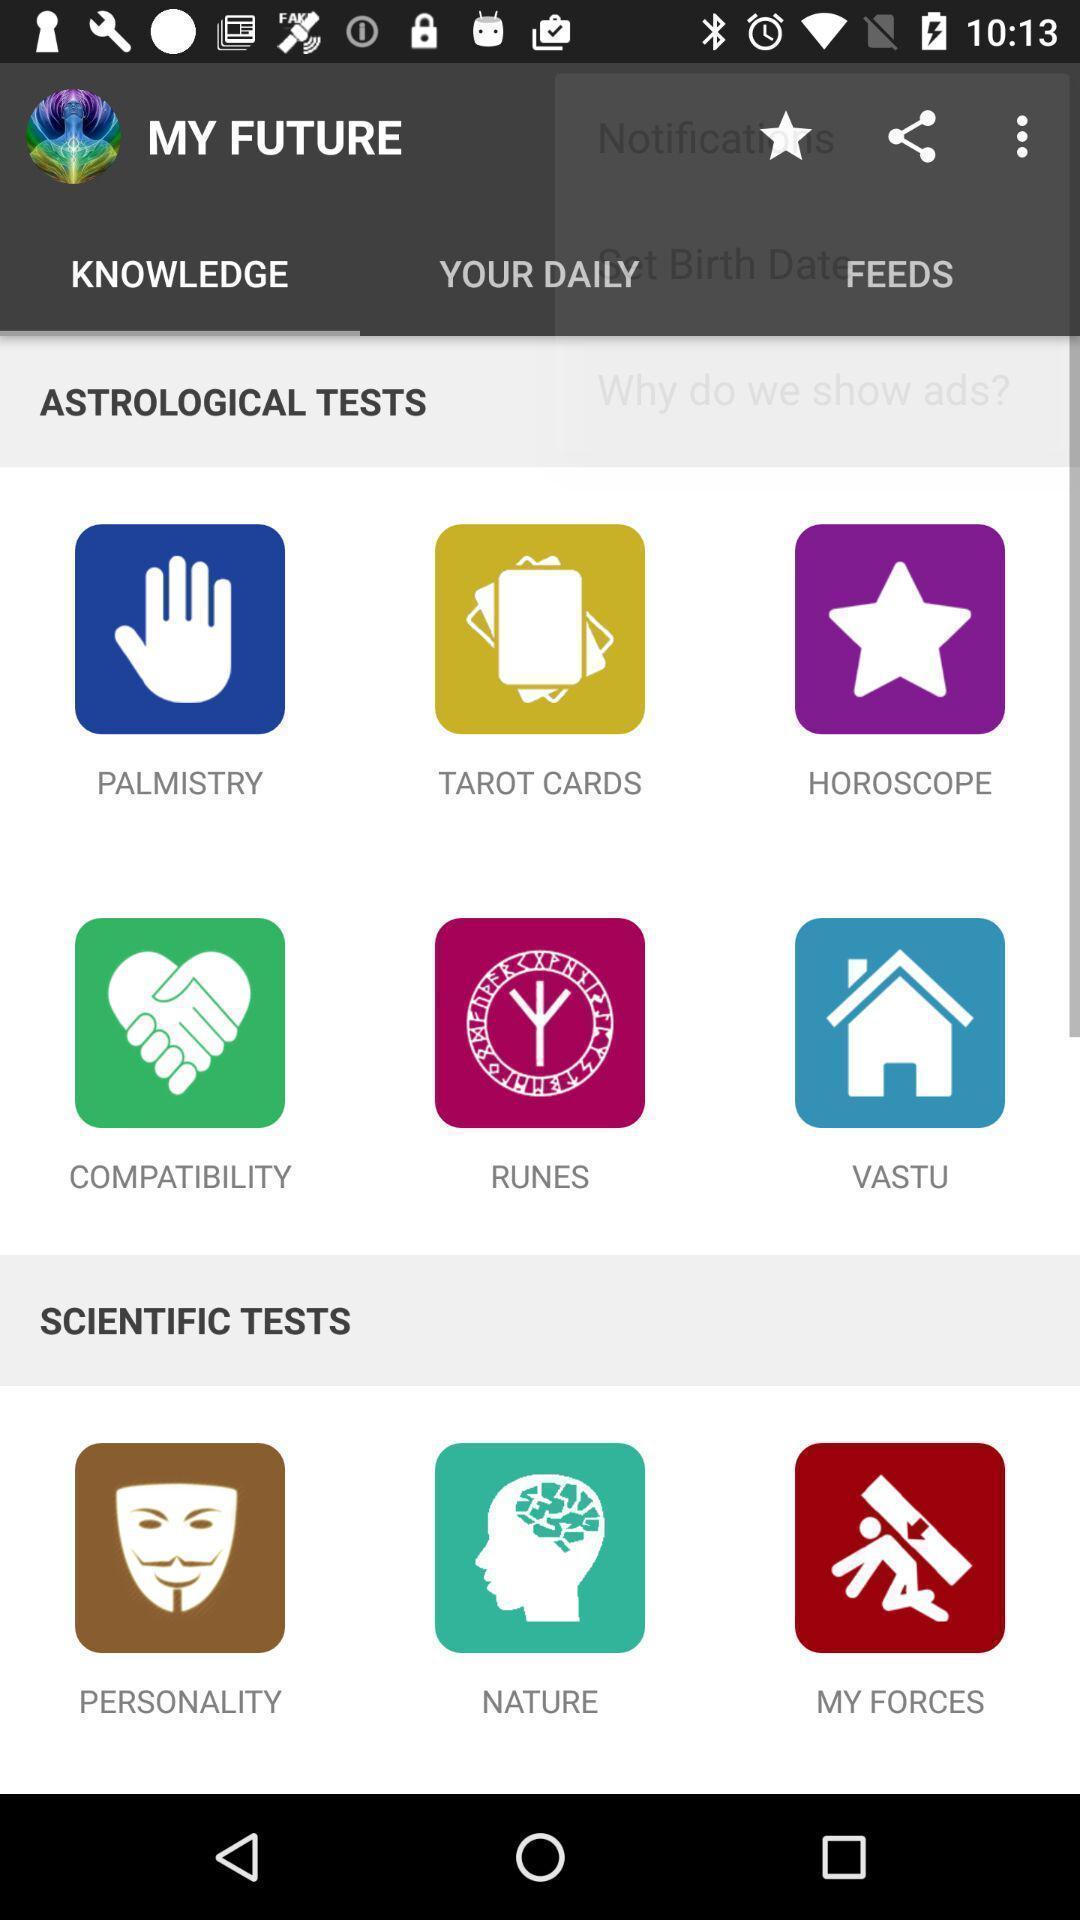Provide a detailed account of this screenshot. Various test options with different tabs in application. 